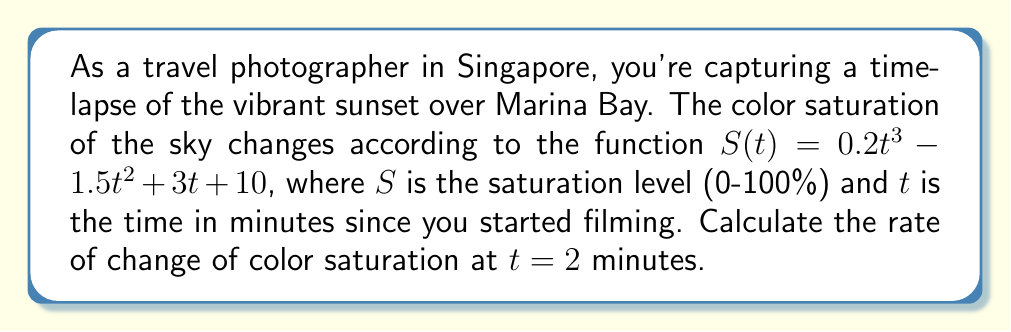Can you solve this math problem? To find the rate of change of color saturation at a specific time, we need to calculate the derivative of the saturation function $S(t)$ and evaluate it at $t = 2$ minutes.

Step 1: Find the derivative of $S(t)$
$$S(t) = 0.2t^3 - 1.5t^2 + 3t + 10$$
$$S'(t) = 0.6t^2 - 3t + 3$$

Step 2: Evaluate $S'(t)$ at $t = 2$
$$S'(2) = 0.6(2)^2 - 3(2) + 3$$
$$S'(2) = 0.6(4) - 6 + 3$$
$$S'(2) = 2.4 - 6 + 3$$
$$S'(2) = -0.6$$

The negative value indicates that the color saturation is decreasing at this moment.
Answer: $-0.6$ %/min 